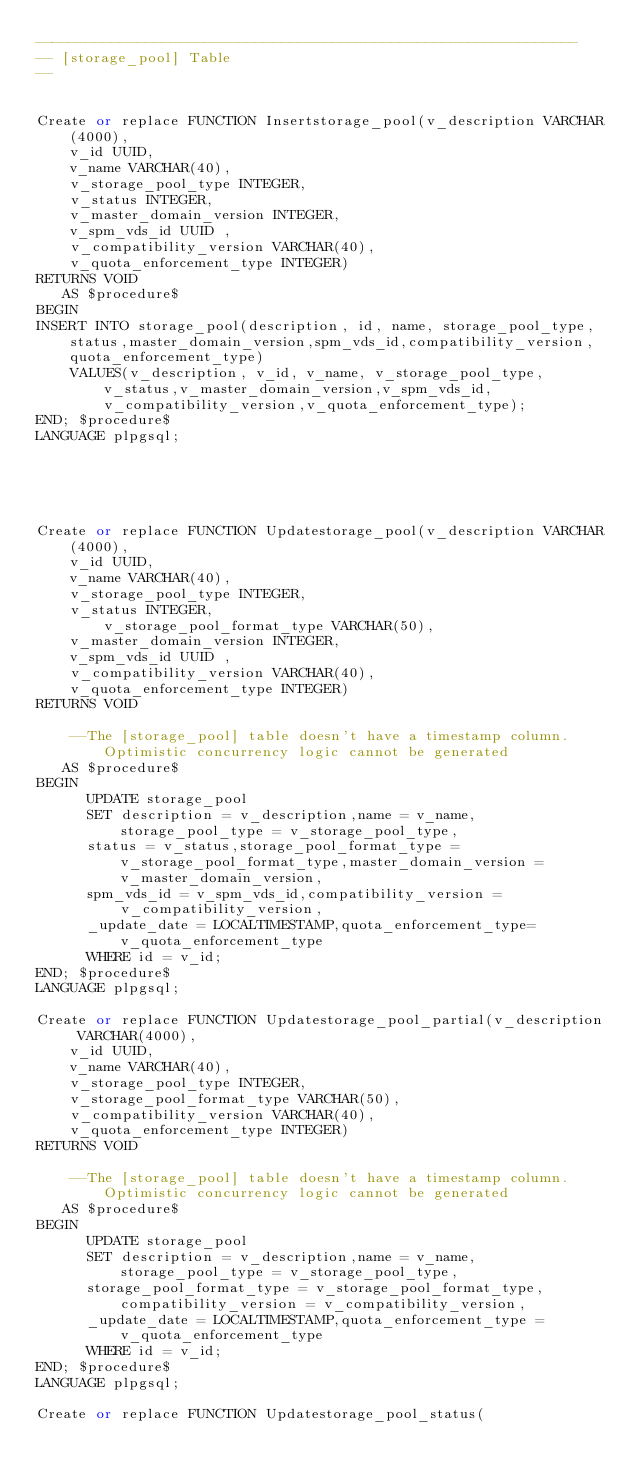Convert code to text. <code><loc_0><loc_0><loc_500><loc_500><_SQL_>----------------------------------------------------------------
-- [storage_pool] Table
--


Create or replace FUNCTION Insertstorage_pool(v_description VARCHAR(4000),
	v_id UUID,
	v_name VARCHAR(40),
	v_storage_pool_type INTEGER,
	v_status INTEGER,
	v_master_domain_version INTEGER,
	v_spm_vds_id UUID ,
	v_compatibility_version VARCHAR(40),
	v_quota_enforcement_type INTEGER)
RETURNS VOID
   AS $procedure$
BEGIN
INSERT INTO storage_pool(description, id, name, storage_pool_type,status,master_domain_version,spm_vds_id,compatibility_version,quota_enforcement_type)
	VALUES(v_description, v_id, v_name, v_storage_pool_type,v_status,v_master_domain_version,v_spm_vds_id,v_compatibility_version,v_quota_enforcement_type);
END; $procedure$
LANGUAGE plpgsql;    





Create or replace FUNCTION Updatestorage_pool(v_description VARCHAR(4000),
	v_id UUID,
	v_name VARCHAR(40),
	v_storage_pool_type INTEGER,
	v_status INTEGER,
        v_storage_pool_format_type VARCHAR(50),
	v_master_domain_version INTEGER,
	v_spm_vds_id UUID ,
	v_compatibility_version VARCHAR(40),
	v_quota_enforcement_type INTEGER)
RETURNS VOID

	--The [storage_pool] table doesn't have a timestamp column. Optimistic concurrency logic cannot be generated
   AS $procedure$
BEGIN
      UPDATE storage_pool
      SET description = v_description,name = v_name,storage_pool_type = v_storage_pool_type, 
      status = v_status,storage_pool_format_type = v_storage_pool_format_type,master_domain_version = v_master_domain_version, 
      spm_vds_id = v_spm_vds_id,compatibility_version = v_compatibility_version, 
      _update_date = LOCALTIMESTAMP,quota_enforcement_type=v_quota_enforcement_type
      WHERE id = v_id;
END; $procedure$
LANGUAGE plpgsql;

Create or replace FUNCTION Updatestorage_pool_partial(v_description VARCHAR(4000),
	v_id UUID,
	v_name VARCHAR(40),
	v_storage_pool_type INTEGER,
	v_storage_pool_format_type VARCHAR(50),
	v_compatibility_version VARCHAR(40),
	v_quota_enforcement_type INTEGER)
RETURNS VOID

	--The [storage_pool] table doesn't have a timestamp column. Optimistic concurrency logic cannot be generated
   AS $procedure$
BEGIN
      UPDATE storage_pool
      SET description = v_description,name = v_name,storage_pool_type = v_storage_pool_type,
      storage_pool_format_type = v_storage_pool_format_type,compatibility_version = v_compatibility_version,
      _update_date = LOCALTIMESTAMP,quota_enforcement_type = v_quota_enforcement_type
      WHERE id = v_id;
END; $procedure$
LANGUAGE plpgsql;

Create or replace FUNCTION Updatestorage_pool_status(</code> 